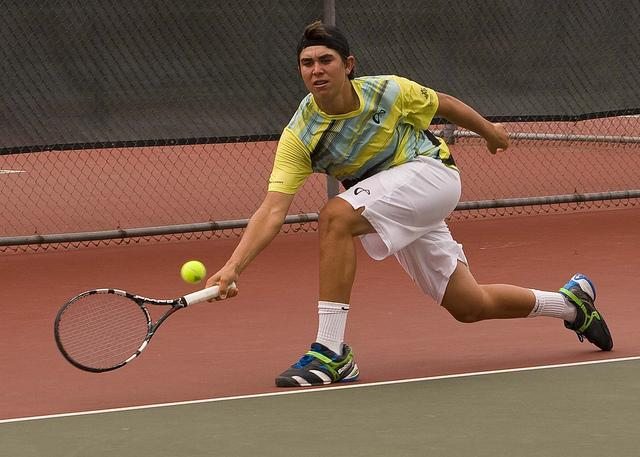What shot is he using to hit the ball? forehand 